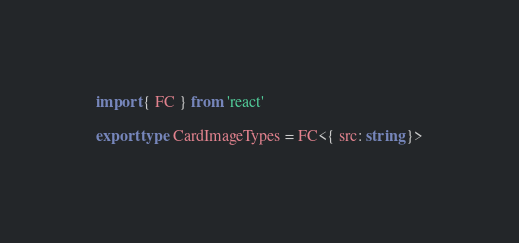Convert code to text. <code><loc_0><loc_0><loc_500><loc_500><_TypeScript_>import { FC } from 'react'

export type CardImageTypes = FC<{ src: string }>
</code> 